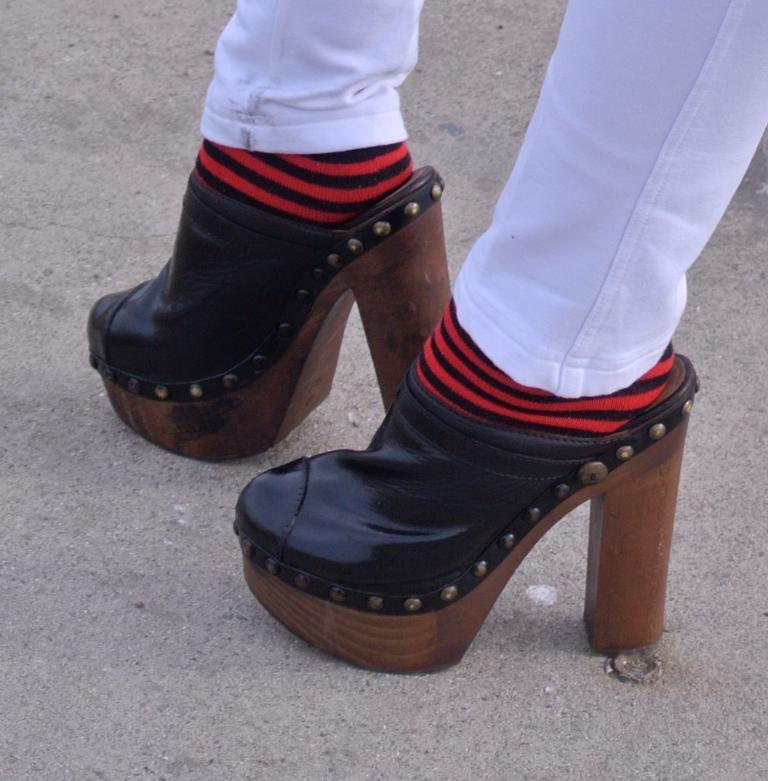What is the main subject of the image? The main subject of the image is two legs. Can you describe the position or appearance of the legs? Unfortunately, the provided facts do not give any information about the position or appearance of the legs. What actor is standing next to the mailbox in the image? There is no actor or mailbox present in the image; the image only features two legs. 